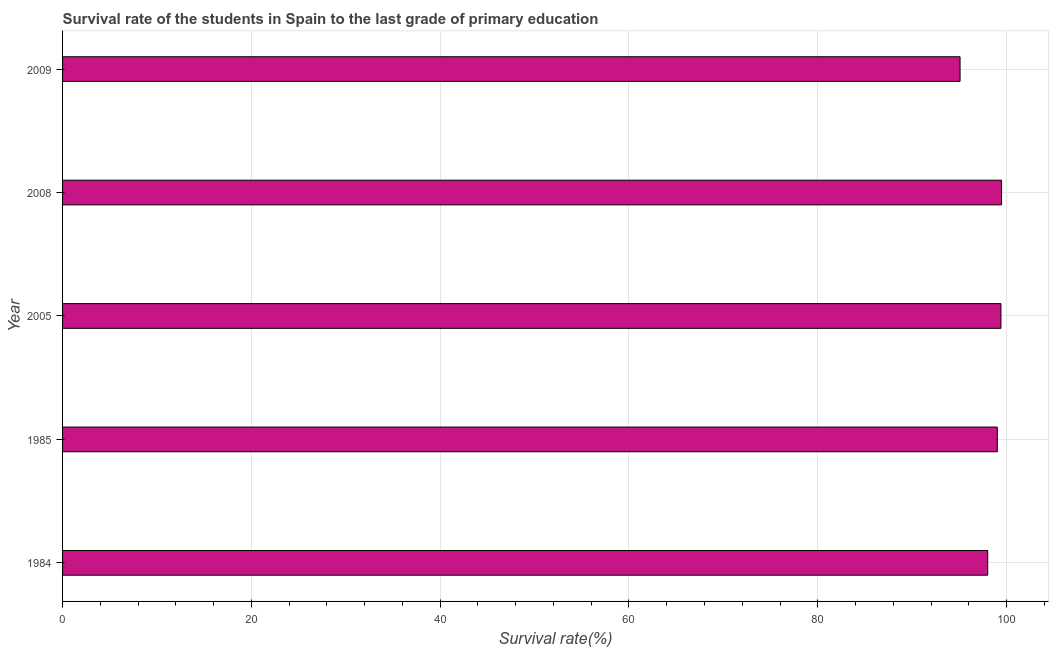What is the title of the graph?
Your answer should be very brief. Survival rate of the students in Spain to the last grade of primary education. What is the label or title of the X-axis?
Provide a succinct answer. Survival rate(%). What is the label or title of the Y-axis?
Ensure brevity in your answer.  Year. What is the survival rate in primary education in 2005?
Provide a short and direct response. 99.4. Across all years, what is the maximum survival rate in primary education?
Offer a terse response. 99.47. Across all years, what is the minimum survival rate in primary education?
Your answer should be very brief. 95.07. In which year was the survival rate in primary education minimum?
Make the answer very short. 2009. What is the sum of the survival rate in primary education?
Keep it short and to the point. 490.96. What is the difference between the survival rate in primary education in 1984 and 2008?
Your answer should be very brief. -1.46. What is the average survival rate in primary education per year?
Your answer should be very brief. 98.19. What is the median survival rate in primary education?
Make the answer very short. 99.02. In how many years, is the survival rate in primary education greater than 100 %?
Keep it short and to the point. 0. Do a majority of the years between 2008 and 1985 (inclusive) have survival rate in primary education greater than 48 %?
Provide a short and direct response. Yes. What is the difference between the highest and the second highest survival rate in primary education?
Provide a succinct answer. 0.06. Is the sum of the survival rate in primary education in 1985 and 2008 greater than the maximum survival rate in primary education across all years?
Give a very brief answer. Yes. What is the difference between the highest and the lowest survival rate in primary education?
Make the answer very short. 4.39. Are all the bars in the graph horizontal?
Provide a succinct answer. Yes. How many years are there in the graph?
Give a very brief answer. 5. What is the Survival rate(%) in 1984?
Provide a succinct answer. 98. What is the Survival rate(%) of 1985?
Your answer should be compact. 99.02. What is the Survival rate(%) of 2005?
Offer a terse response. 99.4. What is the Survival rate(%) of 2008?
Offer a terse response. 99.47. What is the Survival rate(%) of 2009?
Give a very brief answer. 95.07. What is the difference between the Survival rate(%) in 1984 and 1985?
Provide a succinct answer. -1.02. What is the difference between the Survival rate(%) in 1984 and 2005?
Keep it short and to the point. -1.4. What is the difference between the Survival rate(%) in 1984 and 2008?
Offer a terse response. -1.46. What is the difference between the Survival rate(%) in 1984 and 2009?
Provide a short and direct response. 2.93. What is the difference between the Survival rate(%) in 1985 and 2005?
Make the answer very short. -0.39. What is the difference between the Survival rate(%) in 1985 and 2008?
Ensure brevity in your answer.  -0.45. What is the difference between the Survival rate(%) in 1985 and 2009?
Ensure brevity in your answer.  3.94. What is the difference between the Survival rate(%) in 2005 and 2008?
Ensure brevity in your answer.  -0.06. What is the difference between the Survival rate(%) in 2005 and 2009?
Provide a short and direct response. 4.33. What is the difference between the Survival rate(%) in 2008 and 2009?
Provide a succinct answer. 4.39. What is the ratio of the Survival rate(%) in 1984 to that in 2005?
Make the answer very short. 0.99. What is the ratio of the Survival rate(%) in 1984 to that in 2009?
Provide a succinct answer. 1.03. What is the ratio of the Survival rate(%) in 1985 to that in 2009?
Offer a terse response. 1.04. What is the ratio of the Survival rate(%) in 2005 to that in 2009?
Offer a very short reply. 1.05. What is the ratio of the Survival rate(%) in 2008 to that in 2009?
Your response must be concise. 1.05. 